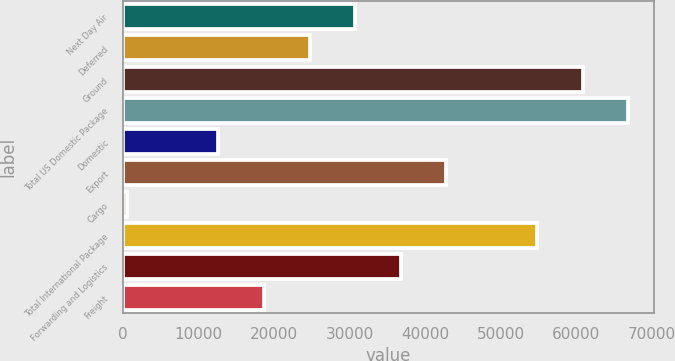Convert chart to OTSL. <chart><loc_0><loc_0><loc_500><loc_500><bar_chart><fcel>Next Day Air<fcel>Deferred<fcel>Ground<fcel>Total US Domestic Package<fcel>Domestic<fcel>Export<fcel>Cargo<fcel>Total International Package<fcel>Forwarding and Logistics<fcel>Freight<nl><fcel>30720.5<fcel>24683.4<fcel>60906<fcel>66943.1<fcel>12609.2<fcel>42794.7<fcel>535<fcel>54868.9<fcel>36757.6<fcel>18646.3<nl></chart> 